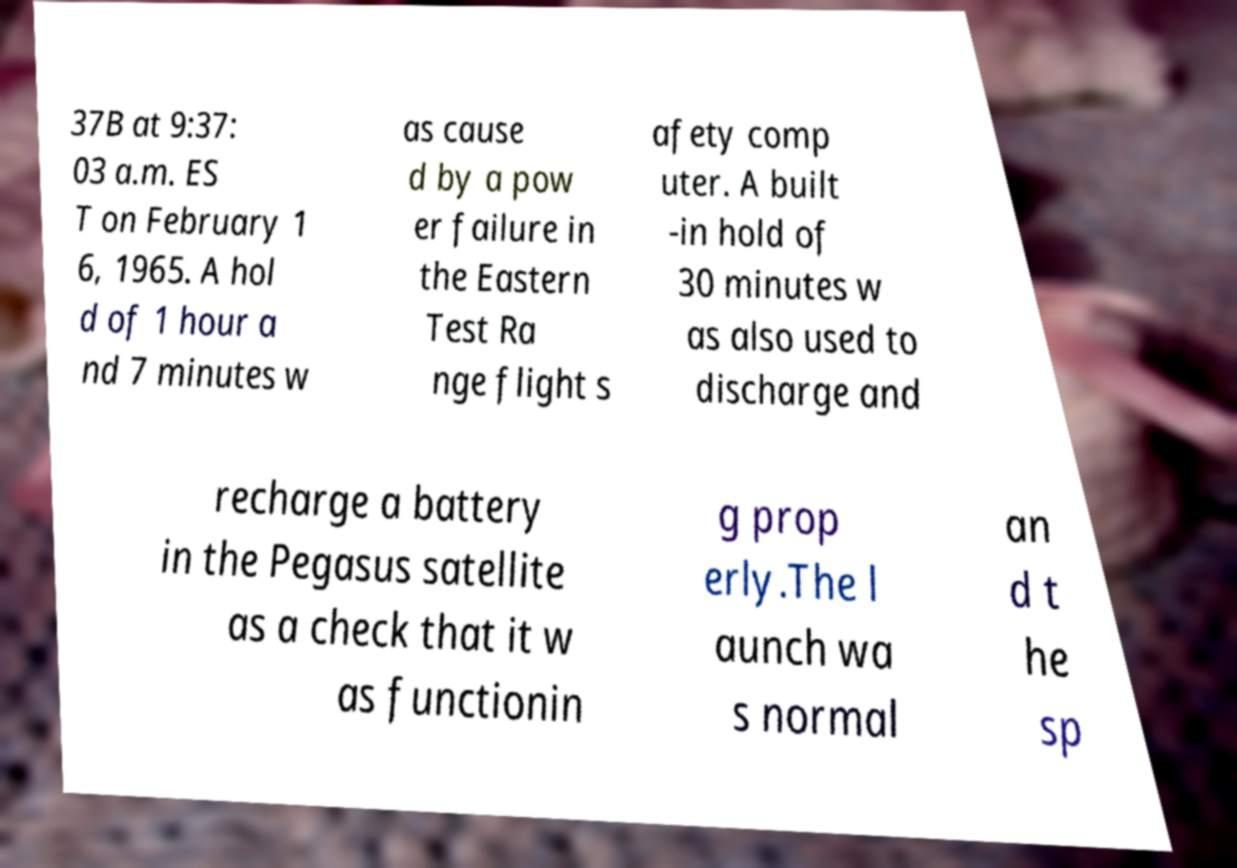What messages or text are displayed in this image? I need them in a readable, typed format. 37B at 9:37: 03 a.m. ES T on February 1 6, 1965. A hol d of 1 hour a nd 7 minutes w as cause d by a pow er failure in the Eastern Test Ra nge flight s afety comp uter. A built -in hold of 30 minutes w as also used to discharge and recharge a battery in the Pegasus satellite as a check that it w as functionin g prop erly.The l aunch wa s normal an d t he sp 